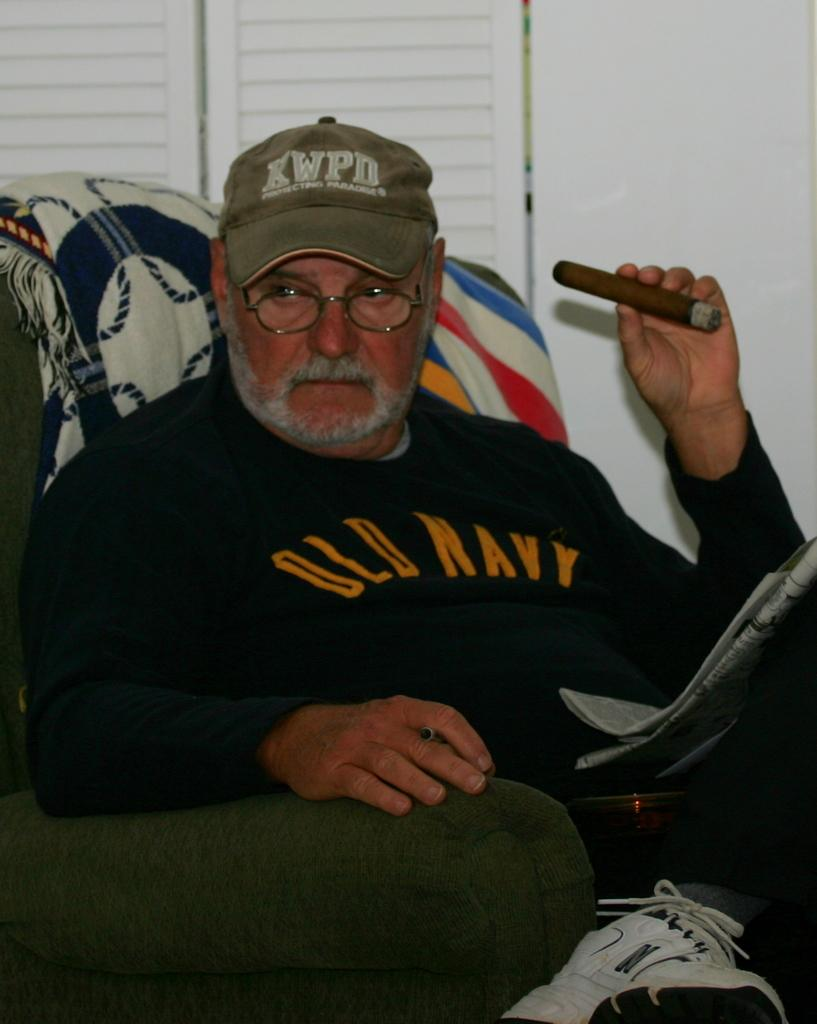Provide a one-sentence caption for the provided image. The man in the chair is wearing an Old Navy sweatshirt and a KWPD cap. 